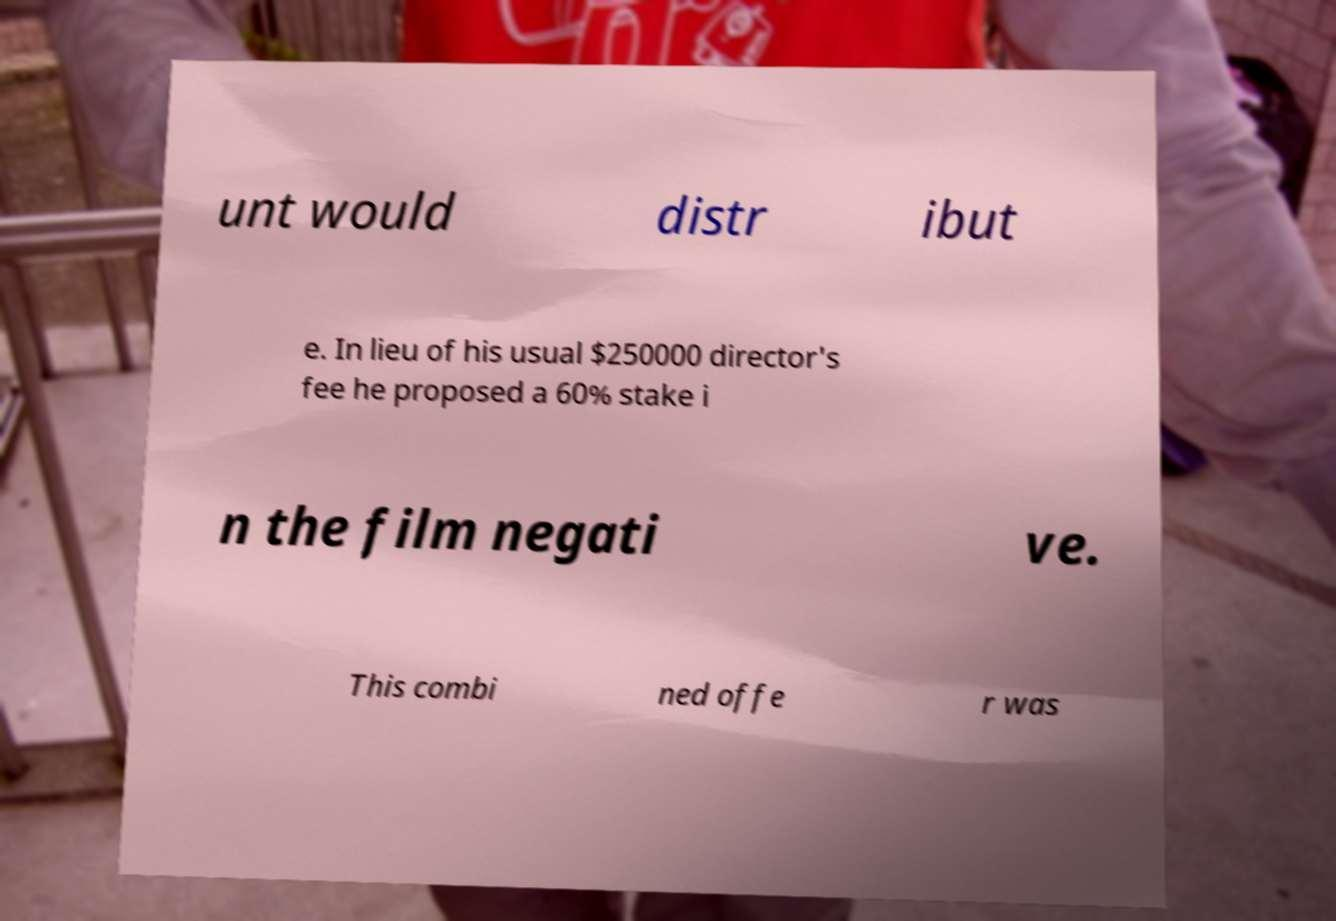There's text embedded in this image that I need extracted. Can you transcribe it verbatim? unt would distr ibut e. In lieu of his usual $250000 director's fee he proposed a 60% stake i n the film negati ve. This combi ned offe r was 